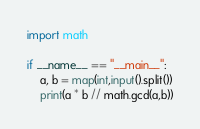Convert code to text. <code><loc_0><loc_0><loc_500><loc_500><_Python_>import math

if __name__ == "__main__":
    a, b = map(int,input().split())
    print(a * b // math.gcd(a,b))</code> 